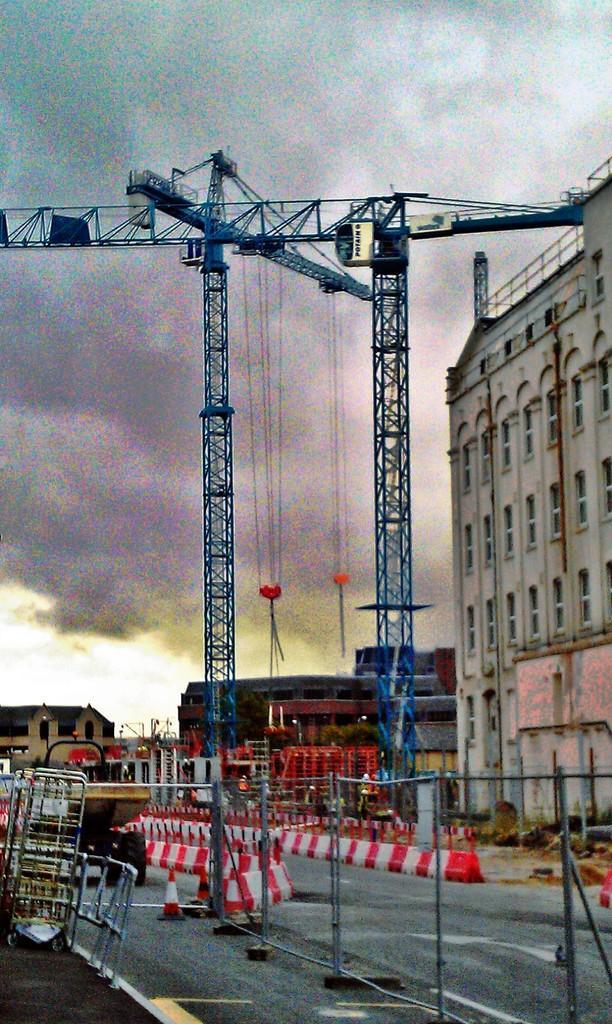Could you give a brief overview of what you see in this image? In this picture we can see there are cranes and buildings. In front of the cranes, there are barricades, traffic cones and some other objects. Behind the cranes there is the cloudy sky. 